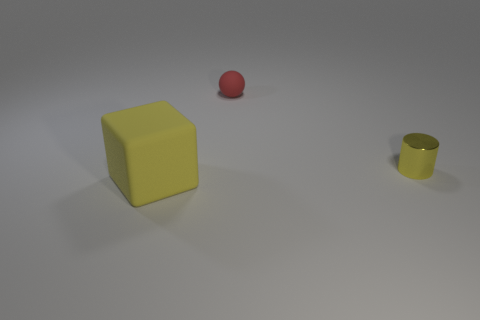Add 2 tiny red spheres. How many objects exist? 5 Subtract all blocks. How many objects are left? 2 Subtract 0 cyan cylinders. How many objects are left? 3 Subtract all large yellow metallic objects. Subtract all yellow objects. How many objects are left? 1 Add 1 big objects. How many big objects are left? 2 Add 3 large purple objects. How many large purple objects exist? 3 